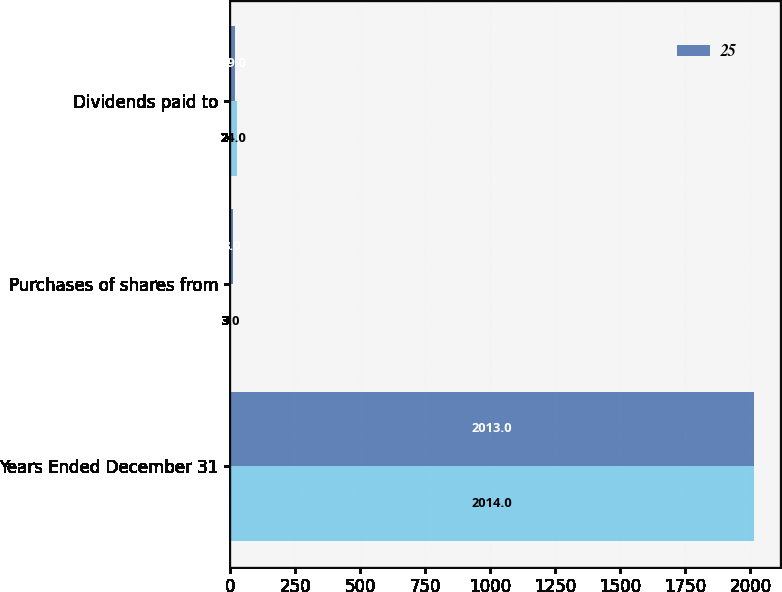Convert chart to OTSL. <chart><loc_0><loc_0><loc_500><loc_500><stacked_bar_chart><ecel><fcel>Years Ended December 31<fcel>Purchases of shares from<fcel>Dividends paid to<nl><fcel>nan<fcel>2014<fcel>3<fcel>24<nl><fcel>25<fcel>2013<fcel>8<fcel>19<nl></chart> 